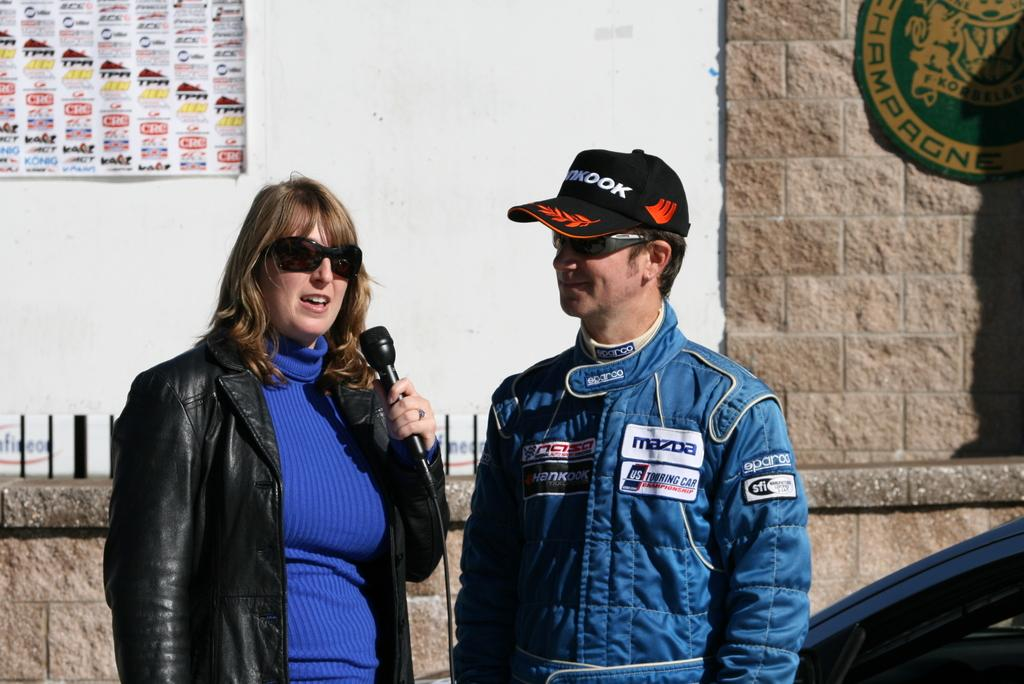<image>
Summarize the visual content of the image. Male race car driver in a Mazda logo blue jacket standing by a lady. 